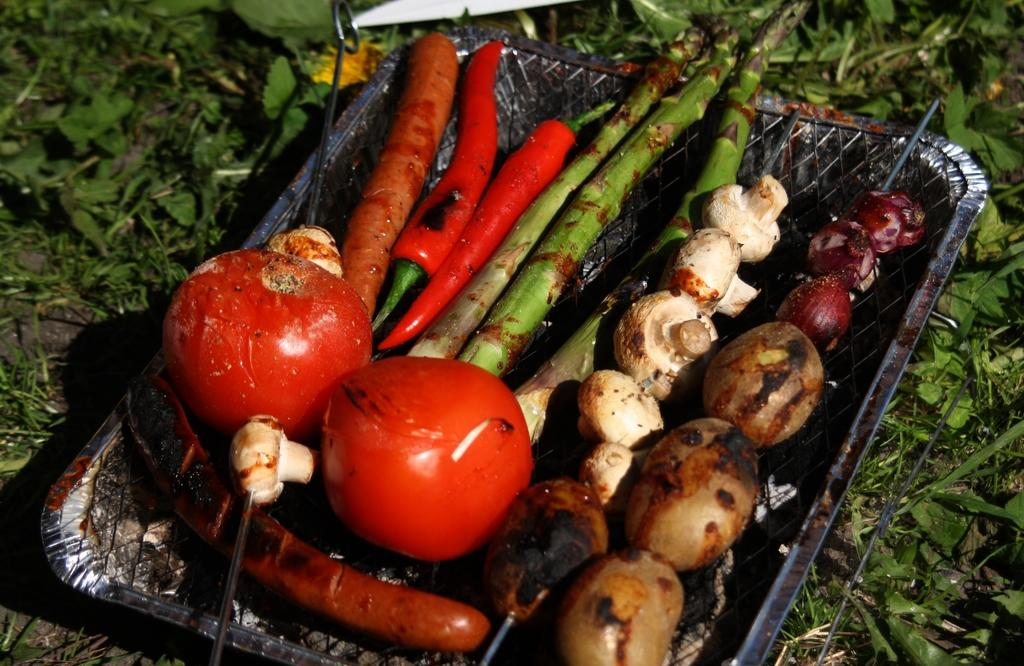What types of food can be seen in the image? There are different vegetables in the image. How are the vegetables being prepared? The vegetables are on a grilling pad. What is the natural setting visible in the image? There is grass around the vegetables. Can you see a girl swimming in the image? There is no girl swimming in the image; it features vegetables on a grilling pad with grass in the background. 